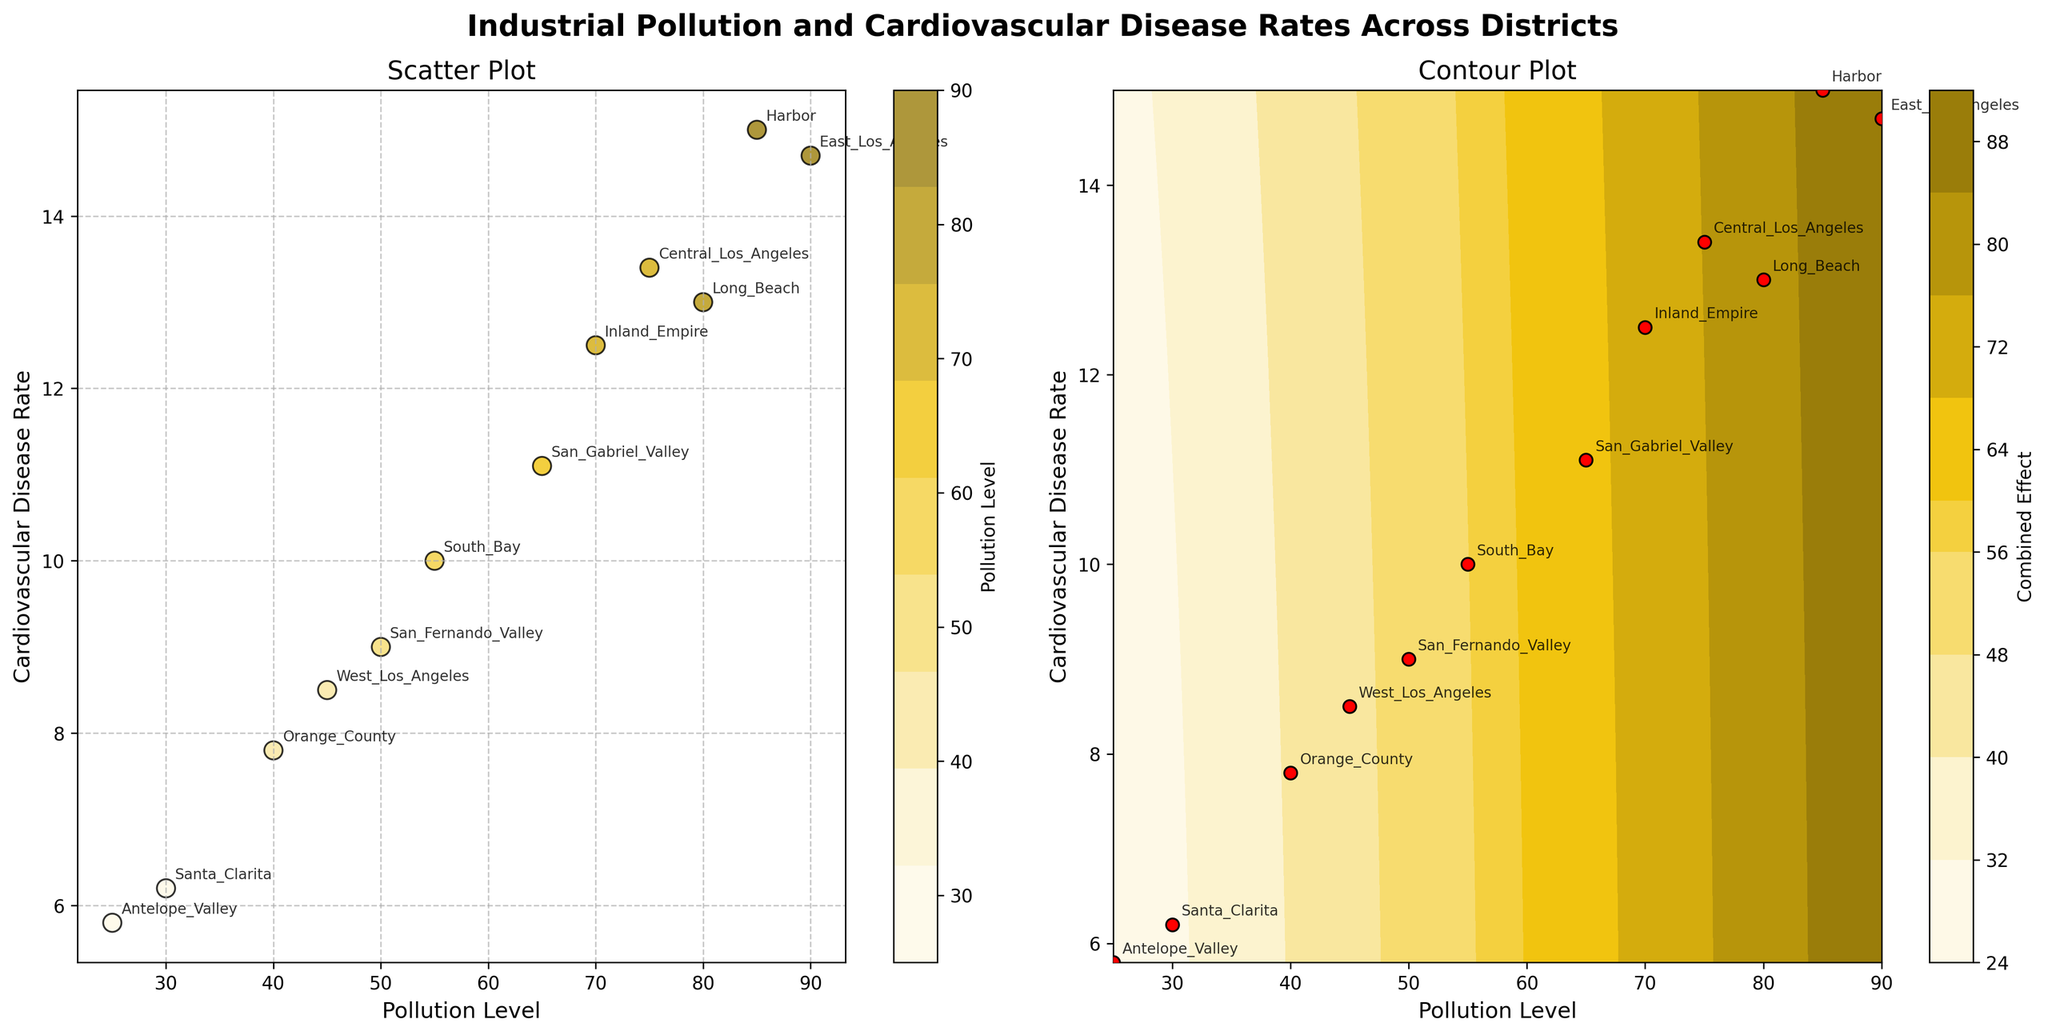What's the title of the figure? The title of the figure is displayed prominently at the top, summarizing the content of the plots.
Answer: Industrial Pollution and Cardiovascular Disease Rates Across Districts How are the pollution levels represented in the scatter plot? The pollution levels are represented by the color of the markers in the scatter plot, with a color gradient indicating different pollution intensities.
Answer: By color gradient Which district has the highest pollution level? By looking at the scatter plot, the highest pollution level can be identified by the district corresponding to the marker with the darkest color.
Answer: East Los Angeles What is the relationship between pollution level and cardiovascular disease rate observed in the scatter plot? By observing the scatter plot, we see a trend where higher pollution levels generally correspond to higher cardiovascular disease rates.
Answer: They are positively correlated In the contour plot, what color represents the highest combined effect of pollution level and cardiovascular disease rate? In the contour plot, the areas with the darkest colors (towards brown) represent the highest combined effect of pollution level and cardiovascular disease rate.
Answer: Dark brown Which district has the lowest cardiovascular disease rate? By observing the position of points on the y-axis of the scatter plot, the district with the lowest cardiovascular disease rate can be identified.
Answer: Antelope Valley Compare the cardiovascular disease rates of Long Beach and Central Los Angeles. Which is higher? By looking at the scatter plot, compare the y-values of the markers for Long Beach and Central Los Angeles.
Answer: Central Los Angeles How does the disease rate in Santa Clarita compare to that in Inland Empire? By locating the positions of Santa Clarita and Inland Empire on the scatter plot, we see that the disease rate is lower in Santa Clarita.
Answer: Lower Estimate the pollution level at which the cardiovascular disease rate crosses 10% in the contour plot. By examining the contour lines on the contour plot, find the approximate x-value where the contour line for a cardiovascular disease rate of 10% intersects.
Answer: Around 55 How many districts have pollution levels below 50? By counting the markers below the x-value of 50 on the scatter plot, we can determine the number of such districts.
Answer: 4 